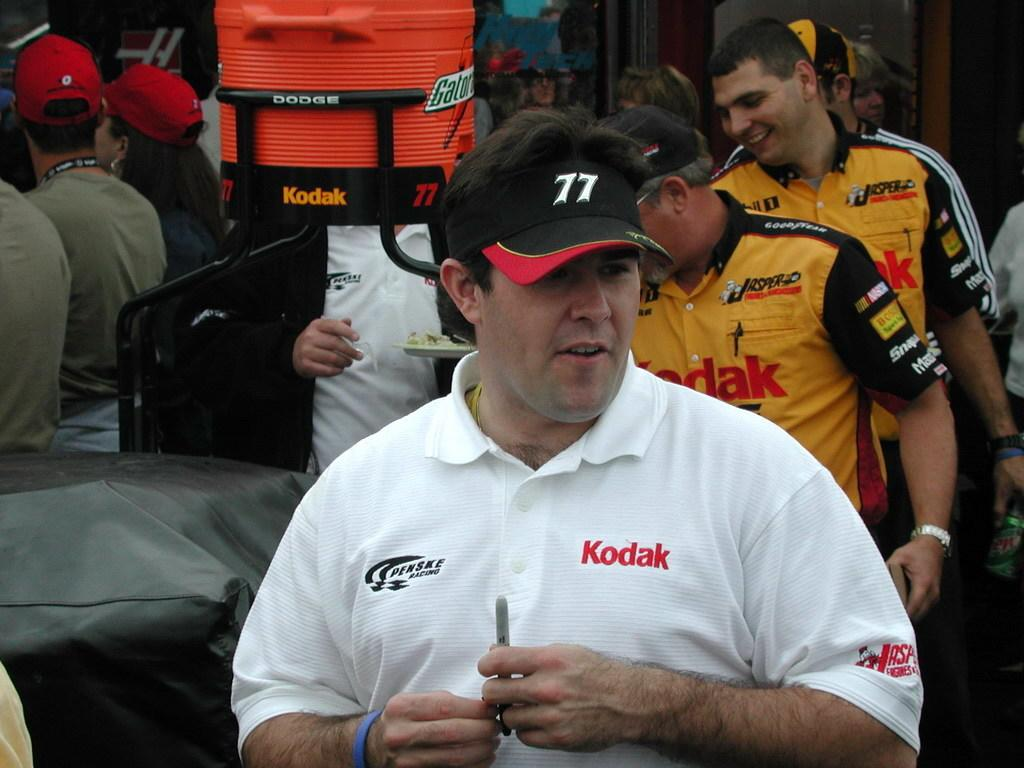<image>
Write a terse but informative summary of the picture. a man wearing a black hat and white shirt with Kodak written in red on it 